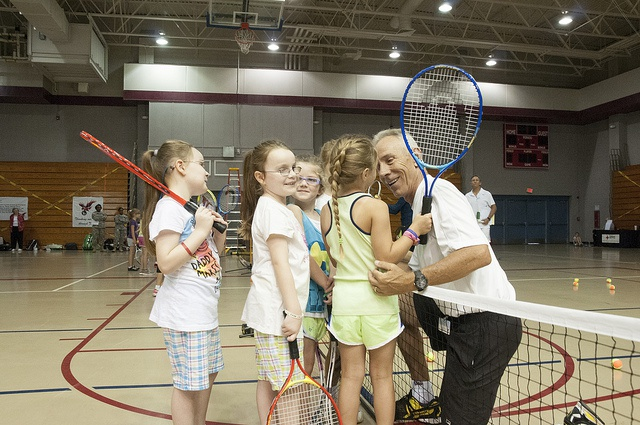Describe the objects in this image and their specific colors. I can see people in black, white, tan, and darkgray tones, people in black, khaki, tan, beige, and gray tones, people in black, lightgray, tan, and darkgray tones, people in black, ivory, and tan tones, and tennis racket in black, darkgray, gray, and lightgray tones in this image. 